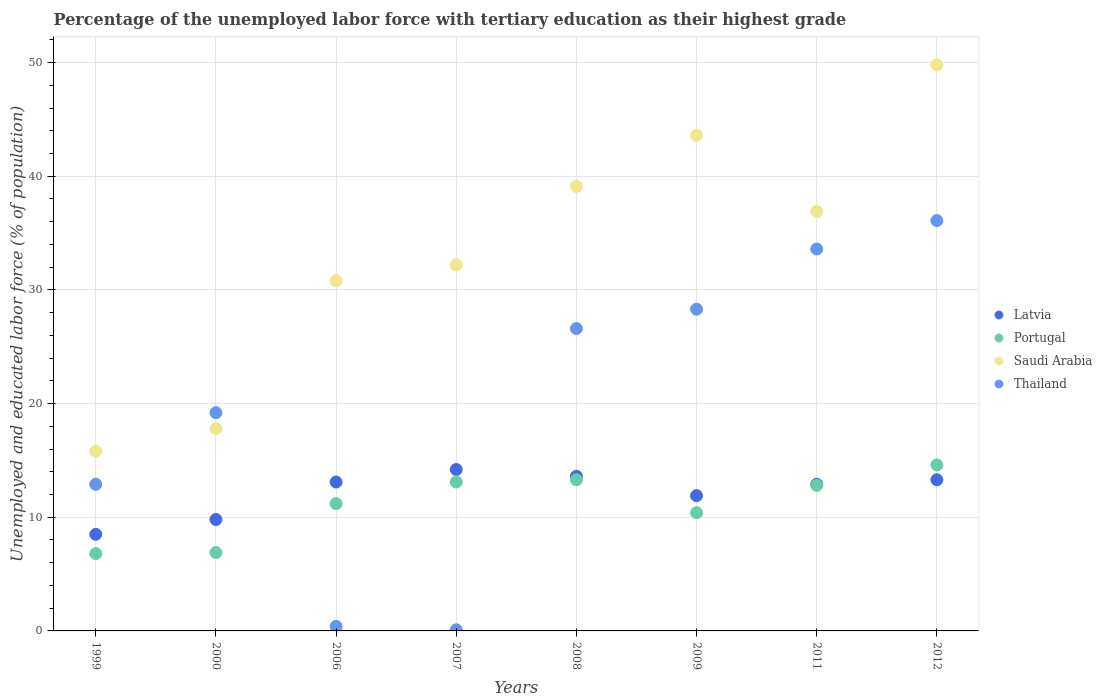How many different coloured dotlines are there?
Offer a very short reply. 4. What is the percentage of the unemployed labor force with tertiary education in Latvia in 1999?
Your response must be concise. 8.5. Across all years, what is the maximum percentage of the unemployed labor force with tertiary education in Thailand?
Ensure brevity in your answer.  36.1. Across all years, what is the minimum percentage of the unemployed labor force with tertiary education in Latvia?
Provide a succinct answer. 8.5. In which year was the percentage of the unemployed labor force with tertiary education in Thailand maximum?
Your response must be concise. 2012. In which year was the percentage of the unemployed labor force with tertiary education in Saudi Arabia minimum?
Your answer should be compact. 1999. What is the total percentage of the unemployed labor force with tertiary education in Portugal in the graph?
Provide a succinct answer. 89.1. What is the difference between the percentage of the unemployed labor force with tertiary education in Latvia in 2006 and that in 2007?
Your answer should be very brief. -1.1. What is the difference between the percentage of the unemployed labor force with tertiary education in Latvia in 2006 and the percentage of the unemployed labor force with tertiary education in Saudi Arabia in 2012?
Your answer should be compact. -36.7. What is the average percentage of the unemployed labor force with tertiary education in Portugal per year?
Your answer should be very brief. 11.14. In the year 2000, what is the difference between the percentage of the unemployed labor force with tertiary education in Saudi Arabia and percentage of the unemployed labor force with tertiary education in Latvia?
Provide a short and direct response. 8. What is the ratio of the percentage of the unemployed labor force with tertiary education in Latvia in 2007 to that in 2009?
Ensure brevity in your answer.  1.19. What is the difference between the highest and the second highest percentage of the unemployed labor force with tertiary education in Saudi Arabia?
Give a very brief answer. 6.2. What is the difference between the highest and the lowest percentage of the unemployed labor force with tertiary education in Thailand?
Make the answer very short. 36. In how many years, is the percentage of the unemployed labor force with tertiary education in Thailand greater than the average percentage of the unemployed labor force with tertiary education in Thailand taken over all years?
Offer a very short reply. 4. Is it the case that in every year, the sum of the percentage of the unemployed labor force with tertiary education in Latvia and percentage of the unemployed labor force with tertiary education in Saudi Arabia  is greater than the percentage of the unemployed labor force with tertiary education in Thailand?
Your answer should be compact. Yes. Does the percentage of the unemployed labor force with tertiary education in Portugal monotonically increase over the years?
Offer a terse response. No. Is the percentage of the unemployed labor force with tertiary education in Thailand strictly greater than the percentage of the unemployed labor force with tertiary education in Latvia over the years?
Your answer should be compact. No. Is the percentage of the unemployed labor force with tertiary education in Latvia strictly less than the percentage of the unemployed labor force with tertiary education in Saudi Arabia over the years?
Provide a short and direct response. Yes. How many dotlines are there?
Offer a terse response. 4. How many years are there in the graph?
Give a very brief answer. 8. Are the values on the major ticks of Y-axis written in scientific E-notation?
Offer a terse response. No. Does the graph contain any zero values?
Keep it short and to the point. No. What is the title of the graph?
Your answer should be very brief. Percentage of the unemployed labor force with tertiary education as their highest grade. Does "Gambia, The" appear as one of the legend labels in the graph?
Provide a short and direct response. No. What is the label or title of the X-axis?
Ensure brevity in your answer.  Years. What is the label or title of the Y-axis?
Your response must be concise. Unemployed and educated labor force (% of population). What is the Unemployed and educated labor force (% of population) in Latvia in 1999?
Keep it short and to the point. 8.5. What is the Unemployed and educated labor force (% of population) in Portugal in 1999?
Offer a terse response. 6.8. What is the Unemployed and educated labor force (% of population) of Saudi Arabia in 1999?
Provide a succinct answer. 15.8. What is the Unemployed and educated labor force (% of population) in Thailand in 1999?
Provide a short and direct response. 12.9. What is the Unemployed and educated labor force (% of population) in Latvia in 2000?
Your answer should be compact. 9.8. What is the Unemployed and educated labor force (% of population) of Portugal in 2000?
Provide a short and direct response. 6.9. What is the Unemployed and educated labor force (% of population) in Saudi Arabia in 2000?
Your answer should be very brief. 17.8. What is the Unemployed and educated labor force (% of population) of Thailand in 2000?
Give a very brief answer. 19.2. What is the Unemployed and educated labor force (% of population) of Latvia in 2006?
Your answer should be very brief. 13.1. What is the Unemployed and educated labor force (% of population) in Portugal in 2006?
Provide a succinct answer. 11.2. What is the Unemployed and educated labor force (% of population) of Saudi Arabia in 2006?
Your response must be concise. 30.8. What is the Unemployed and educated labor force (% of population) in Thailand in 2006?
Provide a short and direct response. 0.4. What is the Unemployed and educated labor force (% of population) of Latvia in 2007?
Keep it short and to the point. 14.2. What is the Unemployed and educated labor force (% of population) of Portugal in 2007?
Your answer should be compact. 13.1. What is the Unemployed and educated labor force (% of population) of Saudi Arabia in 2007?
Ensure brevity in your answer.  32.2. What is the Unemployed and educated labor force (% of population) of Thailand in 2007?
Give a very brief answer. 0.1. What is the Unemployed and educated labor force (% of population) in Latvia in 2008?
Give a very brief answer. 13.6. What is the Unemployed and educated labor force (% of population) of Portugal in 2008?
Ensure brevity in your answer.  13.3. What is the Unemployed and educated labor force (% of population) in Saudi Arabia in 2008?
Your answer should be compact. 39.1. What is the Unemployed and educated labor force (% of population) in Thailand in 2008?
Offer a terse response. 26.6. What is the Unemployed and educated labor force (% of population) in Latvia in 2009?
Keep it short and to the point. 11.9. What is the Unemployed and educated labor force (% of population) of Portugal in 2009?
Make the answer very short. 10.4. What is the Unemployed and educated labor force (% of population) in Saudi Arabia in 2009?
Your response must be concise. 43.6. What is the Unemployed and educated labor force (% of population) of Thailand in 2009?
Provide a short and direct response. 28.3. What is the Unemployed and educated labor force (% of population) of Latvia in 2011?
Ensure brevity in your answer.  12.9. What is the Unemployed and educated labor force (% of population) of Portugal in 2011?
Make the answer very short. 12.8. What is the Unemployed and educated labor force (% of population) of Saudi Arabia in 2011?
Your answer should be compact. 36.9. What is the Unemployed and educated labor force (% of population) in Thailand in 2011?
Make the answer very short. 33.6. What is the Unemployed and educated labor force (% of population) in Latvia in 2012?
Provide a short and direct response. 13.3. What is the Unemployed and educated labor force (% of population) in Portugal in 2012?
Your answer should be compact. 14.6. What is the Unemployed and educated labor force (% of population) of Saudi Arabia in 2012?
Your answer should be compact. 49.8. What is the Unemployed and educated labor force (% of population) of Thailand in 2012?
Ensure brevity in your answer.  36.1. Across all years, what is the maximum Unemployed and educated labor force (% of population) in Latvia?
Keep it short and to the point. 14.2. Across all years, what is the maximum Unemployed and educated labor force (% of population) of Portugal?
Give a very brief answer. 14.6. Across all years, what is the maximum Unemployed and educated labor force (% of population) of Saudi Arabia?
Make the answer very short. 49.8. Across all years, what is the maximum Unemployed and educated labor force (% of population) of Thailand?
Provide a short and direct response. 36.1. Across all years, what is the minimum Unemployed and educated labor force (% of population) of Latvia?
Provide a short and direct response. 8.5. Across all years, what is the minimum Unemployed and educated labor force (% of population) of Portugal?
Offer a terse response. 6.8. Across all years, what is the minimum Unemployed and educated labor force (% of population) of Saudi Arabia?
Provide a short and direct response. 15.8. Across all years, what is the minimum Unemployed and educated labor force (% of population) of Thailand?
Ensure brevity in your answer.  0.1. What is the total Unemployed and educated labor force (% of population) in Latvia in the graph?
Your answer should be very brief. 97.3. What is the total Unemployed and educated labor force (% of population) of Portugal in the graph?
Make the answer very short. 89.1. What is the total Unemployed and educated labor force (% of population) in Saudi Arabia in the graph?
Offer a very short reply. 266. What is the total Unemployed and educated labor force (% of population) in Thailand in the graph?
Keep it short and to the point. 157.2. What is the difference between the Unemployed and educated labor force (% of population) of Latvia in 1999 and that in 2000?
Your response must be concise. -1.3. What is the difference between the Unemployed and educated labor force (% of population) of Portugal in 1999 and that in 2000?
Your response must be concise. -0.1. What is the difference between the Unemployed and educated labor force (% of population) in Saudi Arabia in 1999 and that in 2006?
Provide a succinct answer. -15. What is the difference between the Unemployed and educated labor force (% of population) of Thailand in 1999 and that in 2006?
Ensure brevity in your answer.  12.5. What is the difference between the Unemployed and educated labor force (% of population) in Portugal in 1999 and that in 2007?
Your answer should be compact. -6.3. What is the difference between the Unemployed and educated labor force (% of population) in Saudi Arabia in 1999 and that in 2007?
Make the answer very short. -16.4. What is the difference between the Unemployed and educated labor force (% of population) of Latvia in 1999 and that in 2008?
Offer a terse response. -5.1. What is the difference between the Unemployed and educated labor force (% of population) in Portugal in 1999 and that in 2008?
Offer a very short reply. -6.5. What is the difference between the Unemployed and educated labor force (% of population) in Saudi Arabia in 1999 and that in 2008?
Make the answer very short. -23.3. What is the difference between the Unemployed and educated labor force (% of population) of Thailand in 1999 and that in 2008?
Ensure brevity in your answer.  -13.7. What is the difference between the Unemployed and educated labor force (% of population) of Saudi Arabia in 1999 and that in 2009?
Make the answer very short. -27.8. What is the difference between the Unemployed and educated labor force (% of population) of Thailand in 1999 and that in 2009?
Give a very brief answer. -15.4. What is the difference between the Unemployed and educated labor force (% of population) of Latvia in 1999 and that in 2011?
Offer a terse response. -4.4. What is the difference between the Unemployed and educated labor force (% of population) in Portugal in 1999 and that in 2011?
Offer a very short reply. -6. What is the difference between the Unemployed and educated labor force (% of population) of Saudi Arabia in 1999 and that in 2011?
Offer a very short reply. -21.1. What is the difference between the Unemployed and educated labor force (% of population) of Thailand in 1999 and that in 2011?
Provide a short and direct response. -20.7. What is the difference between the Unemployed and educated labor force (% of population) in Latvia in 1999 and that in 2012?
Provide a short and direct response. -4.8. What is the difference between the Unemployed and educated labor force (% of population) of Portugal in 1999 and that in 2012?
Offer a terse response. -7.8. What is the difference between the Unemployed and educated labor force (% of population) of Saudi Arabia in 1999 and that in 2012?
Your response must be concise. -34. What is the difference between the Unemployed and educated labor force (% of population) of Thailand in 1999 and that in 2012?
Offer a terse response. -23.2. What is the difference between the Unemployed and educated labor force (% of population) of Portugal in 2000 and that in 2006?
Provide a succinct answer. -4.3. What is the difference between the Unemployed and educated labor force (% of population) in Saudi Arabia in 2000 and that in 2006?
Provide a short and direct response. -13. What is the difference between the Unemployed and educated labor force (% of population) in Thailand in 2000 and that in 2006?
Keep it short and to the point. 18.8. What is the difference between the Unemployed and educated labor force (% of population) of Latvia in 2000 and that in 2007?
Make the answer very short. -4.4. What is the difference between the Unemployed and educated labor force (% of population) in Portugal in 2000 and that in 2007?
Make the answer very short. -6.2. What is the difference between the Unemployed and educated labor force (% of population) in Saudi Arabia in 2000 and that in 2007?
Your response must be concise. -14.4. What is the difference between the Unemployed and educated labor force (% of population) in Thailand in 2000 and that in 2007?
Make the answer very short. 19.1. What is the difference between the Unemployed and educated labor force (% of population) of Latvia in 2000 and that in 2008?
Your answer should be very brief. -3.8. What is the difference between the Unemployed and educated labor force (% of population) of Portugal in 2000 and that in 2008?
Your answer should be very brief. -6.4. What is the difference between the Unemployed and educated labor force (% of population) in Saudi Arabia in 2000 and that in 2008?
Provide a succinct answer. -21.3. What is the difference between the Unemployed and educated labor force (% of population) of Saudi Arabia in 2000 and that in 2009?
Ensure brevity in your answer.  -25.8. What is the difference between the Unemployed and educated labor force (% of population) of Thailand in 2000 and that in 2009?
Provide a succinct answer. -9.1. What is the difference between the Unemployed and educated labor force (% of population) in Latvia in 2000 and that in 2011?
Your response must be concise. -3.1. What is the difference between the Unemployed and educated labor force (% of population) in Portugal in 2000 and that in 2011?
Ensure brevity in your answer.  -5.9. What is the difference between the Unemployed and educated labor force (% of population) in Saudi Arabia in 2000 and that in 2011?
Your answer should be very brief. -19.1. What is the difference between the Unemployed and educated labor force (% of population) of Thailand in 2000 and that in 2011?
Keep it short and to the point. -14.4. What is the difference between the Unemployed and educated labor force (% of population) of Saudi Arabia in 2000 and that in 2012?
Your answer should be compact. -32. What is the difference between the Unemployed and educated labor force (% of population) in Thailand in 2000 and that in 2012?
Keep it short and to the point. -16.9. What is the difference between the Unemployed and educated labor force (% of population) of Latvia in 2006 and that in 2007?
Your answer should be compact. -1.1. What is the difference between the Unemployed and educated labor force (% of population) in Portugal in 2006 and that in 2007?
Provide a short and direct response. -1.9. What is the difference between the Unemployed and educated labor force (% of population) of Latvia in 2006 and that in 2008?
Provide a short and direct response. -0.5. What is the difference between the Unemployed and educated labor force (% of population) in Portugal in 2006 and that in 2008?
Your answer should be compact. -2.1. What is the difference between the Unemployed and educated labor force (% of population) of Saudi Arabia in 2006 and that in 2008?
Offer a very short reply. -8.3. What is the difference between the Unemployed and educated labor force (% of population) of Thailand in 2006 and that in 2008?
Your response must be concise. -26.2. What is the difference between the Unemployed and educated labor force (% of population) in Thailand in 2006 and that in 2009?
Your answer should be compact. -27.9. What is the difference between the Unemployed and educated labor force (% of population) of Latvia in 2006 and that in 2011?
Make the answer very short. 0.2. What is the difference between the Unemployed and educated labor force (% of population) of Portugal in 2006 and that in 2011?
Your response must be concise. -1.6. What is the difference between the Unemployed and educated labor force (% of population) of Thailand in 2006 and that in 2011?
Provide a short and direct response. -33.2. What is the difference between the Unemployed and educated labor force (% of population) of Portugal in 2006 and that in 2012?
Keep it short and to the point. -3.4. What is the difference between the Unemployed and educated labor force (% of population) of Saudi Arabia in 2006 and that in 2012?
Your answer should be compact. -19. What is the difference between the Unemployed and educated labor force (% of population) in Thailand in 2006 and that in 2012?
Offer a very short reply. -35.7. What is the difference between the Unemployed and educated labor force (% of population) of Latvia in 2007 and that in 2008?
Your response must be concise. 0.6. What is the difference between the Unemployed and educated labor force (% of population) in Saudi Arabia in 2007 and that in 2008?
Your response must be concise. -6.9. What is the difference between the Unemployed and educated labor force (% of population) in Thailand in 2007 and that in 2008?
Your answer should be compact. -26.5. What is the difference between the Unemployed and educated labor force (% of population) in Thailand in 2007 and that in 2009?
Give a very brief answer. -28.2. What is the difference between the Unemployed and educated labor force (% of population) of Latvia in 2007 and that in 2011?
Make the answer very short. 1.3. What is the difference between the Unemployed and educated labor force (% of population) of Portugal in 2007 and that in 2011?
Provide a short and direct response. 0.3. What is the difference between the Unemployed and educated labor force (% of population) in Saudi Arabia in 2007 and that in 2011?
Your response must be concise. -4.7. What is the difference between the Unemployed and educated labor force (% of population) in Thailand in 2007 and that in 2011?
Keep it short and to the point. -33.5. What is the difference between the Unemployed and educated labor force (% of population) in Latvia in 2007 and that in 2012?
Keep it short and to the point. 0.9. What is the difference between the Unemployed and educated labor force (% of population) of Portugal in 2007 and that in 2012?
Your response must be concise. -1.5. What is the difference between the Unemployed and educated labor force (% of population) in Saudi Arabia in 2007 and that in 2012?
Offer a terse response. -17.6. What is the difference between the Unemployed and educated labor force (% of population) of Thailand in 2007 and that in 2012?
Give a very brief answer. -36. What is the difference between the Unemployed and educated labor force (% of population) in Latvia in 2008 and that in 2009?
Keep it short and to the point. 1.7. What is the difference between the Unemployed and educated labor force (% of population) in Portugal in 2008 and that in 2009?
Keep it short and to the point. 2.9. What is the difference between the Unemployed and educated labor force (% of population) of Thailand in 2008 and that in 2009?
Give a very brief answer. -1.7. What is the difference between the Unemployed and educated labor force (% of population) in Latvia in 2008 and that in 2011?
Make the answer very short. 0.7. What is the difference between the Unemployed and educated labor force (% of population) of Portugal in 2008 and that in 2011?
Make the answer very short. 0.5. What is the difference between the Unemployed and educated labor force (% of population) in Portugal in 2008 and that in 2012?
Make the answer very short. -1.3. What is the difference between the Unemployed and educated labor force (% of population) of Saudi Arabia in 2008 and that in 2012?
Your answer should be compact. -10.7. What is the difference between the Unemployed and educated labor force (% of population) of Thailand in 2008 and that in 2012?
Keep it short and to the point. -9.5. What is the difference between the Unemployed and educated labor force (% of population) of Latvia in 2009 and that in 2012?
Provide a succinct answer. -1.4. What is the difference between the Unemployed and educated labor force (% of population) of Portugal in 2009 and that in 2012?
Your answer should be very brief. -4.2. What is the difference between the Unemployed and educated labor force (% of population) in Latvia in 2011 and that in 2012?
Your answer should be very brief. -0.4. What is the difference between the Unemployed and educated labor force (% of population) of Portugal in 2011 and that in 2012?
Offer a very short reply. -1.8. What is the difference between the Unemployed and educated labor force (% of population) in Latvia in 1999 and the Unemployed and educated labor force (% of population) in Portugal in 2000?
Provide a short and direct response. 1.6. What is the difference between the Unemployed and educated labor force (% of population) of Latvia in 1999 and the Unemployed and educated labor force (% of population) of Saudi Arabia in 2000?
Provide a succinct answer. -9.3. What is the difference between the Unemployed and educated labor force (% of population) of Saudi Arabia in 1999 and the Unemployed and educated labor force (% of population) of Thailand in 2000?
Offer a terse response. -3.4. What is the difference between the Unemployed and educated labor force (% of population) in Latvia in 1999 and the Unemployed and educated labor force (% of population) in Saudi Arabia in 2006?
Provide a short and direct response. -22.3. What is the difference between the Unemployed and educated labor force (% of population) of Latvia in 1999 and the Unemployed and educated labor force (% of population) of Portugal in 2007?
Ensure brevity in your answer.  -4.6. What is the difference between the Unemployed and educated labor force (% of population) of Latvia in 1999 and the Unemployed and educated labor force (% of population) of Saudi Arabia in 2007?
Ensure brevity in your answer.  -23.7. What is the difference between the Unemployed and educated labor force (% of population) in Portugal in 1999 and the Unemployed and educated labor force (% of population) in Saudi Arabia in 2007?
Offer a very short reply. -25.4. What is the difference between the Unemployed and educated labor force (% of population) of Portugal in 1999 and the Unemployed and educated labor force (% of population) of Thailand in 2007?
Make the answer very short. 6.7. What is the difference between the Unemployed and educated labor force (% of population) of Saudi Arabia in 1999 and the Unemployed and educated labor force (% of population) of Thailand in 2007?
Ensure brevity in your answer.  15.7. What is the difference between the Unemployed and educated labor force (% of population) in Latvia in 1999 and the Unemployed and educated labor force (% of population) in Portugal in 2008?
Offer a terse response. -4.8. What is the difference between the Unemployed and educated labor force (% of population) of Latvia in 1999 and the Unemployed and educated labor force (% of population) of Saudi Arabia in 2008?
Give a very brief answer. -30.6. What is the difference between the Unemployed and educated labor force (% of population) of Latvia in 1999 and the Unemployed and educated labor force (% of population) of Thailand in 2008?
Keep it short and to the point. -18.1. What is the difference between the Unemployed and educated labor force (% of population) of Portugal in 1999 and the Unemployed and educated labor force (% of population) of Saudi Arabia in 2008?
Offer a terse response. -32.3. What is the difference between the Unemployed and educated labor force (% of population) in Portugal in 1999 and the Unemployed and educated labor force (% of population) in Thailand in 2008?
Offer a very short reply. -19.8. What is the difference between the Unemployed and educated labor force (% of population) in Saudi Arabia in 1999 and the Unemployed and educated labor force (% of population) in Thailand in 2008?
Provide a succinct answer. -10.8. What is the difference between the Unemployed and educated labor force (% of population) of Latvia in 1999 and the Unemployed and educated labor force (% of population) of Saudi Arabia in 2009?
Keep it short and to the point. -35.1. What is the difference between the Unemployed and educated labor force (% of population) of Latvia in 1999 and the Unemployed and educated labor force (% of population) of Thailand in 2009?
Give a very brief answer. -19.8. What is the difference between the Unemployed and educated labor force (% of population) of Portugal in 1999 and the Unemployed and educated labor force (% of population) of Saudi Arabia in 2009?
Make the answer very short. -36.8. What is the difference between the Unemployed and educated labor force (% of population) in Portugal in 1999 and the Unemployed and educated labor force (% of population) in Thailand in 2009?
Make the answer very short. -21.5. What is the difference between the Unemployed and educated labor force (% of population) of Saudi Arabia in 1999 and the Unemployed and educated labor force (% of population) of Thailand in 2009?
Offer a very short reply. -12.5. What is the difference between the Unemployed and educated labor force (% of population) in Latvia in 1999 and the Unemployed and educated labor force (% of population) in Saudi Arabia in 2011?
Make the answer very short. -28.4. What is the difference between the Unemployed and educated labor force (% of population) of Latvia in 1999 and the Unemployed and educated labor force (% of population) of Thailand in 2011?
Provide a succinct answer. -25.1. What is the difference between the Unemployed and educated labor force (% of population) of Portugal in 1999 and the Unemployed and educated labor force (% of population) of Saudi Arabia in 2011?
Offer a very short reply. -30.1. What is the difference between the Unemployed and educated labor force (% of population) in Portugal in 1999 and the Unemployed and educated labor force (% of population) in Thailand in 2011?
Your answer should be very brief. -26.8. What is the difference between the Unemployed and educated labor force (% of population) of Saudi Arabia in 1999 and the Unemployed and educated labor force (% of population) of Thailand in 2011?
Ensure brevity in your answer.  -17.8. What is the difference between the Unemployed and educated labor force (% of population) in Latvia in 1999 and the Unemployed and educated labor force (% of population) in Saudi Arabia in 2012?
Your answer should be compact. -41.3. What is the difference between the Unemployed and educated labor force (% of population) of Latvia in 1999 and the Unemployed and educated labor force (% of population) of Thailand in 2012?
Keep it short and to the point. -27.6. What is the difference between the Unemployed and educated labor force (% of population) in Portugal in 1999 and the Unemployed and educated labor force (% of population) in Saudi Arabia in 2012?
Keep it short and to the point. -43. What is the difference between the Unemployed and educated labor force (% of population) in Portugal in 1999 and the Unemployed and educated labor force (% of population) in Thailand in 2012?
Ensure brevity in your answer.  -29.3. What is the difference between the Unemployed and educated labor force (% of population) in Saudi Arabia in 1999 and the Unemployed and educated labor force (% of population) in Thailand in 2012?
Ensure brevity in your answer.  -20.3. What is the difference between the Unemployed and educated labor force (% of population) of Latvia in 2000 and the Unemployed and educated labor force (% of population) of Portugal in 2006?
Provide a succinct answer. -1.4. What is the difference between the Unemployed and educated labor force (% of population) in Latvia in 2000 and the Unemployed and educated labor force (% of population) in Saudi Arabia in 2006?
Provide a short and direct response. -21. What is the difference between the Unemployed and educated labor force (% of population) of Latvia in 2000 and the Unemployed and educated labor force (% of population) of Thailand in 2006?
Keep it short and to the point. 9.4. What is the difference between the Unemployed and educated labor force (% of population) of Portugal in 2000 and the Unemployed and educated labor force (% of population) of Saudi Arabia in 2006?
Your response must be concise. -23.9. What is the difference between the Unemployed and educated labor force (% of population) in Saudi Arabia in 2000 and the Unemployed and educated labor force (% of population) in Thailand in 2006?
Ensure brevity in your answer.  17.4. What is the difference between the Unemployed and educated labor force (% of population) in Latvia in 2000 and the Unemployed and educated labor force (% of population) in Saudi Arabia in 2007?
Provide a short and direct response. -22.4. What is the difference between the Unemployed and educated labor force (% of population) of Latvia in 2000 and the Unemployed and educated labor force (% of population) of Thailand in 2007?
Make the answer very short. 9.7. What is the difference between the Unemployed and educated labor force (% of population) in Portugal in 2000 and the Unemployed and educated labor force (% of population) in Saudi Arabia in 2007?
Offer a very short reply. -25.3. What is the difference between the Unemployed and educated labor force (% of population) in Portugal in 2000 and the Unemployed and educated labor force (% of population) in Thailand in 2007?
Offer a very short reply. 6.8. What is the difference between the Unemployed and educated labor force (% of population) of Saudi Arabia in 2000 and the Unemployed and educated labor force (% of population) of Thailand in 2007?
Ensure brevity in your answer.  17.7. What is the difference between the Unemployed and educated labor force (% of population) of Latvia in 2000 and the Unemployed and educated labor force (% of population) of Portugal in 2008?
Make the answer very short. -3.5. What is the difference between the Unemployed and educated labor force (% of population) in Latvia in 2000 and the Unemployed and educated labor force (% of population) in Saudi Arabia in 2008?
Provide a short and direct response. -29.3. What is the difference between the Unemployed and educated labor force (% of population) in Latvia in 2000 and the Unemployed and educated labor force (% of population) in Thailand in 2008?
Offer a very short reply. -16.8. What is the difference between the Unemployed and educated labor force (% of population) in Portugal in 2000 and the Unemployed and educated labor force (% of population) in Saudi Arabia in 2008?
Offer a very short reply. -32.2. What is the difference between the Unemployed and educated labor force (% of population) of Portugal in 2000 and the Unemployed and educated labor force (% of population) of Thailand in 2008?
Keep it short and to the point. -19.7. What is the difference between the Unemployed and educated labor force (% of population) of Saudi Arabia in 2000 and the Unemployed and educated labor force (% of population) of Thailand in 2008?
Make the answer very short. -8.8. What is the difference between the Unemployed and educated labor force (% of population) of Latvia in 2000 and the Unemployed and educated labor force (% of population) of Saudi Arabia in 2009?
Keep it short and to the point. -33.8. What is the difference between the Unemployed and educated labor force (% of population) in Latvia in 2000 and the Unemployed and educated labor force (% of population) in Thailand in 2009?
Your response must be concise. -18.5. What is the difference between the Unemployed and educated labor force (% of population) in Portugal in 2000 and the Unemployed and educated labor force (% of population) in Saudi Arabia in 2009?
Provide a succinct answer. -36.7. What is the difference between the Unemployed and educated labor force (% of population) of Portugal in 2000 and the Unemployed and educated labor force (% of population) of Thailand in 2009?
Your answer should be very brief. -21.4. What is the difference between the Unemployed and educated labor force (% of population) of Latvia in 2000 and the Unemployed and educated labor force (% of population) of Saudi Arabia in 2011?
Provide a succinct answer. -27.1. What is the difference between the Unemployed and educated labor force (% of population) of Latvia in 2000 and the Unemployed and educated labor force (% of population) of Thailand in 2011?
Keep it short and to the point. -23.8. What is the difference between the Unemployed and educated labor force (% of population) in Portugal in 2000 and the Unemployed and educated labor force (% of population) in Saudi Arabia in 2011?
Give a very brief answer. -30. What is the difference between the Unemployed and educated labor force (% of population) of Portugal in 2000 and the Unemployed and educated labor force (% of population) of Thailand in 2011?
Give a very brief answer. -26.7. What is the difference between the Unemployed and educated labor force (% of population) in Saudi Arabia in 2000 and the Unemployed and educated labor force (% of population) in Thailand in 2011?
Provide a succinct answer. -15.8. What is the difference between the Unemployed and educated labor force (% of population) in Latvia in 2000 and the Unemployed and educated labor force (% of population) in Portugal in 2012?
Keep it short and to the point. -4.8. What is the difference between the Unemployed and educated labor force (% of population) in Latvia in 2000 and the Unemployed and educated labor force (% of population) in Thailand in 2012?
Give a very brief answer. -26.3. What is the difference between the Unemployed and educated labor force (% of population) of Portugal in 2000 and the Unemployed and educated labor force (% of population) of Saudi Arabia in 2012?
Your answer should be compact. -42.9. What is the difference between the Unemployed and educated labor force (% of population) in Portugal in 2000 and the Unemployed and educated labor force (% of population) in Thailand in 2012?
Keep it short and to the point. -29.2. What is the difference between the Unemployed and educated labor force (% of population) of Saudi Arabia in 2000 and the Unemployed and educated labor force (% of population) of Thailand in 2012?
Offer a very short reply. -18.3. What is the difference between the Unemployed and educated labor force (% of population) of Latvia in 2006 and the Unemployed and educated labor force (% of population) of Portugal in 2007?
Your response must be concise. 0. What is the difference between the Unemployed and educated labor force (% of population) of Latvia in 2006 and the Unemployed and educated labor force (% of population) of Saudi Arabia in 2007?
Your answer should be very brief. -19.1. What is the difference between the Unemployed and educated labor force (% of population) of Portugal in 2006 and the Unemployed and educated labor force (% of population) of Thailand in 2007?
Make the answer very short. 11.1. What is the difference between the Unemployed and educated labor force (% of population) in Saudi Arabia in 2006 and the Unemployed and educated labor force (% of population) in Thailand in 2007?
Provide a succinct answer. 30.7. What is the difference between the Unemployed and educated labor force (% of population) of Latvia in 2006 and the Unemployed and educated labor force (% of population) of Saudi Arabia in 2008?
Give a very brief answer. -26. What is the difference between the Unemployed and educated labor force (% of population) in Latvia in 2006 and the Unemployed and educated labor force (% of population) in Thailand in 2008?
Keep it short and to the point. -13.5. What is the difference between the Unemployed and educated labor force (% of population) of Portugal in 2006 and the Unemployed and educated labor force (% of population) of Saudi Arabia in 2008?
Your answer should be compact. -27.9. What is the difference between the Unemployed and educated labor force (% of population) of Portugal in 2006 and the Unemployed and educated labor force (% of population) of Thailand in 2008?
Give a very brief answer. -15.4. What is the difference between the Unemployed and educated labor force (% of population) of Latvia in 2006 and the Unemployed and educated labor force (% of population) of Saudi Arabia in 2009?
Provide a short and direct response. -30.5. What is the difference between the Unemployed and educated labor force (% of population) in Latvia in 2006 and the Unemployed and educated labor force (% of population) in Thailand in 2009?
Ensure brevity in your answer.  -15.2. What is the difference between the Unemployed and educated labor force (% of population) of Portugal in 2006 and the Unemployed and educated labor force (% of population) of Saudi Arabia in 2009?
Your response must be concise. -32.4. What is the difference between the Unemployed and educated labor force (% of population) of Portugal in 2006 and the Unemployed and educated labor force (% of population) of Thailand in 2009?
Your answer should be very brief. -17.1. What is the difference between the Unemployed and educated labor force (% of population) in Latvia in 2006 and the Unemployed and educated labor force (% of population) in Saudi Arabia in 2011?
Provide a short and direct response. -23.8. What is the difference between the Unemployed and educated labor force (% of population) of Latvia in 2006 and the Unemployed and educated labor force (% of population) of Thailand in 2011?
Your response must be concise. -20.5. What is the difference between the Unemployed and educated labor force (% of population) of Portugal in 2006 and the Unemployed and educated labor force (% of population) of Saudi Arabia in 2011?
Offer a terse response. -25.7. What is the difference between the Unemployed and educated labor force (% of population) of Portugal in 2006 and the Unemployed and educated labor force (% of population) of Thailand in 2011?
Your answer should be very brief. -22.4. What is the difference between the Unemployed and educated labor force (% of population) of Saudi Arabia in 2006 and the Unemployed and educated labor force (% of population) of Thailand in 2011?
Your answer should be compact. -2.8. What is the difference between the Unemployed and educated labor force (% of population) of Latvia in 2006 and the Unemployed and educated labor force (% of population) of Saudi Arabia in 2012?
Give a very brief answer. -36.7. What is the difference between the Unemployed and educated labor force (% of population) of Latvia in 2006 and the Unemployed and educated labor force (% of population) of Thailand in 2012?
Keep it short and to the point. -23. What is the difference between the Unemployed and educated labor force (% of population) of Portugal in 2006 and the Unemployed and educated labor force (% of population) of Saudi Arabia in 2012?
Give a very brief answer. -38.6. What is the difference between the Unemployed and educated labor force (% of population) in Portugal in 2006 and the Unemployed and educated labor force (% of population) in Thailand in 2012?
Keep it short and to the point. -24.9. What is the difference between the Unemployed and educated labor force (% of population) in Saudi Arabia in 2006 and the Unemployed and educated labor force (% of population) in Thailand in 2012?
Offer a terse response. -5.3. What is the difference between the Unemployed and educated labor force (% of population) of Latvia in 2007 and the Unemployed and educated labor force (% of population) of Saudi Arabia in 2008?
Make the answer very short. -24.9. What is the difference between the Unemployed and educated labor force (% of population) in Portugal in 2007 and the Unemployed and educated labor force (% of population) in Saudi Arabia in 2008?
Provide a short and direct response. -26. What is the difference between the Unemployed and educated labor force (% of population) of Portugal in 2007 and the Unemployed and educated labor force (% of population) of Thailand in 2008?
Your answer should be very brief. -13.5. What is the difference between the Unemployed and educated labor force (% of population) of Latvia in 2007 and the Unemployed and educated labor force (% of population) of Portugal in 2009?
Your answer should be compact. 3.8. What is the difference between the Unemployed and educated labor force (% of population) of Latvia in 2007 and the Unemployed and educated labor force (% of population) of Saudi Arabia in 2009?
Your response must be concise. -29.4. What is the difference between the Unemployed and educated labor force (% of population) of Latvia in 2007 and the Unemployed and educated labor force (% of population) of Thailand in 2009?
Make the answer very short. -14.1. What is the difference between the Unemployed and educated labor force (% of population) in Portugal in 2007 and the Unemployed and educated labor force (% of population) in Saudi Arabia in 2009?
Offer a terse response. -30.5. What is the difference between the Unemployed and educated labor force (% of population) of Portugal in 2007 and the Unemployed and educated labor force (% of population) of Thailand in 2009?
Give a very brief answer. -15.2. What is the difference between the Unemployed and educated labor force (% of population) in Saudi Arabia in 2007 and the Unemployed and educated labor force (% of population) in Thailand in 2009?
Your answer should be compact. 3.9. What is the difference between the Unemployed and educated labor force (% of population) of Latvia in 2007 and the Unemployed and educated labor force (% of population) of Portugal in 2011?
Ensure brevity in your answer.  1.4. What is the difference between the Unemployed and educated labor force (% of population) of Latvia in 2007 and the Unemployed and educated labor force (% of population) of Saudi Arabia in 2011?
Make the answer very short. -22.7. What is the difference between the Unemployed and educated labor force (% of population) in Latvia in 2007 and the Unemployed and educated labor force (% of population) in Thailand in 2011?
Offer a terse response. -19.4. What is the difference between the Unemployed and educated labor force (% of population) of Portugal in 2007 and the Unemployed and educated labor force (% of population) of Saudi Arabia in 2011?
Give a very brief answer. -23.8. What is the difference between the Unemployed and educated labor force (% of population) in Portugal in 2007 and the Unemployed and educated labor force (% of population) in Thailand in 2011?
Your answer should be compact. -20.5. What is the difference between the Unemployed and educated labor force (% of population) in Latvia in 2007 and the Unemployed and educated labor force (% of population) in Portugal in 2012?
Your answer should be very brief. -0.4. What is the difference between the Unemployed and educated labor force (% of population) in Latvia in 2007 and the Unemployed and educated labor force (% of population) in Saudi Arabia in 2012?
Your response must be concise. -35.6. What is the difference between the Unemployed and educated labor force (% of population) of Latvia in 2007 and the Unemployed and educated labor force (% of population) of Thailand in 2012?
Ensure brevity in your answer.  -21.9. What is the difference between the Unemployed and educated labor force (% of population) in Portugal in 2007 and the Unemployed and educated labor force (% of population) in Saudi Arabia in 2012?
Your answer should be very brief. -36.7. What is the difference between the Unemployed and educated labor force (% of population) in Latvia in 2008 and the Unemployed and educated labor force (% of population) in Saudi Arabia in 2009?
Your response must be concise. -30. What is the difference between the Unemployed and educated labor force (% of population) of Latvia in 2008 and the Unemployed and educated labor force (% of population) of Thailand in 2009?
Keep it short and to the point. -14.7. What is the difference between the Unemployed and educated labor force (% of population) in Portugal in 2008 and the Unemployed and educated labor force (% of population) in Saudi Arabia in 2009?
Provide a succinct answer. -30.3. What is the difference between the Unemployed and educated labor force (% of population) of Latvia in 2008 and the Unemployed and educated labor force (% of population) of Saudi Arabia in 2011?
Make the answer very short. -23.3. What is the difference between the Unemployed and educated labor force (% of population) in Latvia in 2008 and the Unemployed and educated labor force (% of population) in Thailand in 2011?
Your answer should be compact. -20. What is the difference between the Unemployed and educated labor force (% of population) of Portugal in 2008 and the Unemployed and educated labor force (% of population) of Saudi Arabia in 2011?
Keep it short and to the point. -23.6. What is the difference between the Unemployed and educated labor force (% of population) of Portugal in 2008 and the Unemployed and educated labor force (% of population) of Thailand in 2011?
Ensure brevity in your answer.  -20.3. What is the difference between the Unemployed and educated labor force (% of population) in Latvia in 2008 and the Unemployed and educated labor force (% of population) in Saudi Arabia in 2012?
Give a very brief answer. -36.2. What is the difference between the Unemployed and educated labor force (% of population) in Latvia in 2008 and the Unemployed and educated labor force (% of population) in Thailand in 2012?
Your answer should be compact. -22.5. What is the difference between the Unemployed and educated labor force (% of population) of Portugal in 2008 and the Unemployed and educated labor force (% of population) of Saudi Arabia in 2012?
Offer a very short reply. -36.5. What is the difference between the Unemployed and educated labor force (% of population) in Portugal in 2008 and the Unemployed and educated labor force (% of population) in Thailand in 2012?
Provide a short and direct response. -22.8. What is the difference between the Unemployed and educated labor force (% of population) of Saudi Arabia in 2008 and the Unemployed and educated labor force (% of population) of Thailand in 2012?
Your answer should be very brief. 3. What is the difference between the Unemployed and educated labor force (% of population) in Latvia in 2009 and the Unemployed and educated labor force (% of population) in Thailand in 2011?
Provide a succinct answer. -21.7. What is the difference between the Unemployed and educated labor force (% of population) of Portugal in 2009 and the Unemployed and educated labor force (% of population) of Saudi Arabia in 2011?
Ensure brevity in your answer.  -26.5. What is the difference between the Unemployed and educated labor force (% of population) in Portugal in 2009 and the Unemployed and educated labor force (% of population) in Thailand in 2011?
Your response must be concise. -23.2. What is the difference between the Unemployed and educated labor force (% of population) in Latvia in 2009 and the Unemployed and educated labor force (% of population) in Portugal in 2012?
Offer a very short reply. -2.7. What is the difference between the Unemployed and educated labor force (% of population) of Latvia in 2009 and the Unemployed and educated labor force (% of population) of Saudi Arabia in 2012?
Your response must be concise. -37.9. What is the difference between the Unemployed and educated labor force (% of population) in Latvia in 2009 and the Unemployed and educated labor force (% of population) in Thailand in 2012?
Give a very brief answer. -24.2. What is the difference between the Unemployed and educated labor force (% of population) of Portugal in 2009 and the Unemployed and educated labor force (% of population) of Saudi Arabia in 2012?
Your answer should be compact. -39.4. What is the difference between the Unemployed and educated labor force (% of population) in Portugal in 2009 and the Unemployed and educated labor force (% of population) in Thailand in 2012?
Your answer should be compact. -25.7. What is the difference between the Unemployed and educated labor force (% of population) of Saudi Arabia in 2009 and the Unemployed and educated labor force (% of population) of Thailand in 2012?
Make the answer very short. 7.5. What is the difference between the Unemployed and educated labor force (% of population) in Latvia in 2011 and the Unemployed and educated labor force (% of population) in Portugal in 2012?
Make the answer very short. -1.7. What is the difference between the Unemployed and educated labor force (% of population) of Latvia in 2011 and the Unemployed and educated labor force (% of population) of Saudi Arabia in 2012?
Your response must be concise. -36.9. What is the difference between the Unemployed and educated labor force (% of population) in Latvia in 2011 and the Unemployed and educated labor force (% of population) in Thailand in 2012?
Your answer should be compact. -23.2. What is the difference between the Unemployed and educated labor force (% of population) in Portugal in 2011 and the Unemployed and educated labor force (% of population) in Saudi Arabia in 2012?
Provide a short and direct response. -37. What is the difference between the Unemployed and educated labor force (% of population) of Portugal in 2011 and the Unemployed and educated labor force (% of population) of Thailand in 2012?
Keep it short and to the point. -23.3. What is the difference between the Unemployed and educated labor force (% of population) in Saudi Arabia in 2011 and the Unemployed and educated labor force (% of population) in Thailand in 2012?
Your answer should be compact. 0.8. What is the average Unemployed and educated labor force (% of population) in Latvia per year?
Keep it short and to the point. 12.16. What is the average Unemployed and educated labor force (% of population) in Portugal per year?
Make the answer very short. 11.14. What is the average Unemployed and educated labor force (% of population) of Saudi Arabia per year?
Your response must be concise. 33.25. What is the average Unemployed and educated labor force (% of population) of Thailand per year?
Offer a very short reply. 19.65. In the year 1999, what is the difference between the Unemployed and educated labor force (% of population) in Latvia and Unemployed and educated labor force (% of population) in Thailand?
Provide a short and direct response. -4.4. In the year 1999, what is the difference between the Unemployed and educated labor force (% of population) in Portugal and Unemployed and educated labor force (% of population) in Thailand?
Ensure brevity in your answer.  -6.1. In the year 1999, what is the difference between the Unemployed and educated labor force (% of population) of Saudi Arabia and Unemployed and educated labor force (% of population) of Thailand?
Make the answer very short. 2.9. In the year 2000, what is the difference between the Unemployed and educated labor force (% of population) of Latvia and Unemployed and educated labor force (% of population) of Thailand?
Keep it short and to the point. -9.4. In the year 2000, what is the difference between the Unemployed and educated labor force (% of population) of Saudi Arabia and Unemployed and educated labor force (% of population) of Thailand?
Keep it short and to the point. -1.4. In the year 2006, what is the difference between the Unemployed and educated labor force (% of population) of Latvia and Unemployed and educated labor force (% of population) of Portugal?
Your answer should be very brief. 1.9. In the year 2006, what is the difference between the Unemployed and educated labor force (% of population) of Latvia and Unemployed and educated labor force (% of population) of Saudi Arabia?
Give a very brief answer. -17.7. In the year 2006, what is the difference between the Unemployed and educated labor force (% of population) in Latvia and Unemployed and educated labor force (% of population) in Thailand?
Provide a succinct answer. 12.7. In the year 2006, what is the difference between the Unemployed and educated labor force (% of population) in Portugal and Unemployed and educated labor force (% of population) in Saudi Arabia?
Give a very brief answer. -19.6. In the year 2006, what is the difference between the Unemployed and educated labor force (% of population) in Portugal and Unemployed and educated labor force (% of population) in Thailand?
Offer a terse response. 10.8. In the year 2006, what is the difference between the Unemployed and educated labor force (% of population) of Saudi Arabia and Unemployed and educated labor force (% of population) of Thailand?
Ensure brevity in your answer.  30.4. In the year 2007, what is the difference between the Unemployed and educated labor force (% of population) in Latvia and Unemployed and educated labor force (% of population) in Saudi Arabia?
Your answer should be very brief. -18. In the year 2007, what is the difference between the Unemployed and educated labor force (% of population) of Latvia and Unemployed and educated labor force (% of population) of Thailand?
Keep it short and to the point. 14.1. In the year 2007, what is the difference between the Unemployed and educated labor force (% of population) in Portugal and Unemployed and educated labor force (% of population) in Saudi Arabia?
Offer a terse response. -19.1. In the year 2007, what is the difference between the Unemployed and educated labor force (% of population) in Saudi Arabia and Unemployed and educated labor force (% of population) in Thailand?
Your response must be concise. 32.1. In the year 2008, what is the difference between the Unemployed and educated labor force (% of population) in Latvia and Unemployed and educated labor force (% of population) in Saudi Arabia?
Your answer should be very brief. -25.5. In the year 2008, what is the difference between the Unemployed and educated labor force (% of population) of Portugal and Unemployed and educated labor force (% of population) of Saudi Arabia?
Provide a short and direct response. -25.8. In the year 2008, what is the difference between the Unemployed and educated labor force (% of population) in Portugal and Unemployed and educated labor force (% of population) in Thailand?
Provide a succinct answer. -13.3. In the year 2009, what is the difference between the Unemployed and educated labor force (% of population) of Latvia and Unemployed and educated labor force (% of population) of Saudi Arabia?
Your answer should be very brief. -31.7. In the year 2009, what is the difference between the Unemployed and educated labor force (% of population) in Latvia and Unemployed and educated labor force (% of population) in Thailand?
Your answer should be very brief. -16.4. In the year 2009, what is the difference between the Unemployed and educated labor force (% of population) in Portugal and Unemployed and educated labor force (% of population) in Saudi Arabia?
Your response must be concise. -33.2. In the year 2009, what is the difference between the Unemployed and educated labor force (% of population) of Portugal and Unemployed and educated labor force (% of population) of Thailand?
Keep it short and to the point. -17.9. In the year 2011, what is the difference between the Unemployed and educated labor force (% of population) of Latvia and Unemployed and educated labor force (% of population) of Portugal?
Provide a succinct answer. 0.1. In the year 2011, what is the difference between the Unemployed and educated labor force (% of population) in Latvia and Unemployed and educated labor force (% of population) in Saudi Arabia?
Make the answer very short. -24. In the year 2011, what is the difference between the Unemployed and educated labor force (% of population) of Latvia and Unemployed and educated labor force (% of population) of Thailand?
Offer a very short reply. -20.7. In the year 2011, what is the difference between the Unemployed and educated labor force (% of population) in Portugal and Unemployed and educated labor force (% of population) in Saudi Arabia?
Your answer should be very brief. -24.1. In the year 2011, what is the difference between the Unemployed and educated labor force (% of population) in Portugal and Unemployed and educated labor force (% of population) in Thailand?
Give a very brief answer. -20.8. In the year 2011, what is the difference between the Unemployed and educated labor force (% of population) in Saudi Arabia and Unemployed and educated labor force (% of population) in Thailand?
Ensure brevity in your answer.  3.3. In the year 2012, what is the difference between the Unemployed and educated labor force (% of population) of Latvia and Unemployed and educated labor force (% of population) of Portugal?
Offer a terse response. -1.3. In the year 2012, what is the difference between the Unemployed and educated labor force (% of population) in Latvia and Unemployed and educated labor force (% of population) in Saudi Arabia?
Provide a short and direct response. -36.5. In the year 2012, what is the difference between the Unemployed and educated labor force (% of population) in Latvia and Unemployed and educated labor force (% of population) in Thailand?
Offer a terse response. -22.8. In the year 2012, what is the difference between the Unemployed and educated labor force (% of population) in Portugal and Unemployed and educated labor force (% of population) in Saudi Arabia?
Ensure brevity in your answer.  -35.2. In the year 2012, what is the difference between the Unemployed and educated labor force (% of population) in Portugal and Unemployed and educated labor force (% of population) in Thailand?
Make the answer very short. -21.5. What is the ratio of the Unemployed and educated labor force (% of population) of Latvia in 1999 to that in 2000?
Provide a succinct answer. 0.87. What is the ratio of the Unemployed and educated labor force (% of population) of Portugal in 1999 to that in 2000?
Ensure brevity in your answer.  0.99. What is the ratio of the Unemployed and educated labor force (% of population) of Saudi Arabia in 1999 to that in 2000?
Offer a very short reply. 0.89. What is the ratio of the Unemployed and educated labor force (% of population) of Thailand in 1999 to that in 2000?
Your response must be concise. 0.67. What is the ratio of the Unemployed and educated labor force (% of population) of Latvia in 1999 to that in 2006?
Your answer should be compact. 0.65. What is the ratio of the Unemployed and educated labor force (% of population) of Portugal in 1999 to that in 2006?
Ensure brevity in your answer.  0.61. What is the ratio of the Unemployed and educated labor force (% of population) in Saudi Arabia in 1999 to that in 2006?
Ensure brevity in your answer.  0.51. What is the ratio of the Unemployed and educated labor force (% of population) of Thailand in 1999 to that in 2006?
Provide a succinct answer. 32.25. What is the ratio of the Unemployed and educated labor force (% of population) in Latvia in 1999 to that in 2007?
Your answer should be very brief. 0.6. What is the ratio of the Unemployed and educated labor force (% of population) of Portugal in 1999 to that in 2007?
Make the answer very short. 0.52. What is the ratio of the Unemployed and educated labor force (% of population) in Saudi Arabia in 1999 to that in 2007?
Your answer should be very brief. 0.49. What is the ratio of the Unemployed and educated labor force (% of population) in Thailand in 1999 to that in 2007?
Your answer should be very brief. 129. What is the ratio of the Unemployed and educated labor force (% of population) of Latvia in 1999 to that in 2008?
Give a very brief answer. 0.62. What is the ratio of the Unemployed and educated labor force (% of population) in Portugal in 1999 to that in 2008?
Give a very brief answer. 0.51. What is the ratio of the Unemployed and educated labor force (% of population) in Saudi Arabia in 1999 to that in 2008?
Offer a very short reply. 0.4. What is the ratio of the Unemployed and educated labor force (% of population) of Thailand in 1999 to that in 2008?
Ensure brevity in your answer.  0.48. What is the ratio of the Unemployed and educated labor force (% of population) in Latvia in 1999 to that in 2009?
Offer a very short reply. 0.71. What is the ratio of the Unemployed and educated labor force (% of population) of Portugal in 1999 to that in 2009?
Provide a succinct answer. 0.65. What is the ratio of the Unemployed and educated labor force (% of population) of Saudi Arabia in 1999 to that in 2009?
Offer a terse response. 0.36. What is the ratio of the Unemployed and educated labor force (% of population) in Thailand in 1999 to that in 2009?
Keep it short and to the point. 0.46. What is the ratio of the Unemployed and educated labor force (% of population) in Latvia in 1999 to that in 2011?
Provide a succinct answer. 0.66. What is the ratio of the Unemployed and educated labor force (% of population) of Portugal in 1999 to that in 2011?
Give a very brief answer. 0.53. What is the ratio of the Unemployed and educated labor force (% of population) of Saudi Arabia in 1999 to that in 2011?
Offer a very short reply. 0.43. What is the ratio of the Unemployed and educated labor force (% of population) in Thailand in 1999 to that in 2011?
Make the answer very short. 0.38. What is the ratio of the Unemployed and educated labor force (% of population) in Latvia in 1999 to that in 2012?
Your answer should be compact. 0.64. What is the ratio of the Unemployed and educated labor force (% of population) in Portugal in 1999 to that in 2012?
Offer a very short reply. 0.47. What is the ratio of the Unemployed and educated labor force (% of population) in Saudi Arabia in 1999 to that in 2012?
Offer a very short reply. 0.32. What is the ratio of the Unemployed and educated labor force (% of population) of Thailand in 1999 to that in 2012?
Ensure brevity in your answer.  0.36. What is the ratio of the Unemployed and educated labor force (% of population) of Latvia in 2000 to that in 2006?
Give a very brief answer. 0.75. What is the ratio of the Unemployed and educated labor force (% of population) in Portugal in 2000 to that in 2006?
Give a very brief answer. 0.62. What is the ratio of the Unemployed and educated labor force (% of population) of Saudi Arabia in 2000 to that in 2006?
Offer a very short reply. 0.58. What is the ratio of the Unemployed and educated labor force (% of population) in Thailand in 2000 to that in 2006?
Ensure brevity in your answer.  48. What is the ratio of the Unemployed and educated labor force (% of population) in Latvia in 2000 to that in 2007?
Your answer should be compact. 0.69. What is the ratio of the Unemployed and educated labor force (% of population) in Portugal in 2000 to that in 2007?
Give a very brief answer. 0.53. What is the ratio of the Unemployed and educated labor force (% of population) of Saudi Arabia in 2000 to that in 2007?
Offer a terse response. 0.55. What is the ratio of the Unemployed and educated labor force (% of population) in Thailand in 2000 to that in 2007?
Offer a very short reply. 192. What is the ratio of the Unemployed and educated labor force (% of population) of Latvia in 2000 to that in 2008?
Keep it short and to the point. 0.72. What is the ratio of the Unemployed and educated labor force (% of population) in Portugal in 2000 to that in 2008?
Keep it short and to the point. 0.52. What is the ratio of the Unemployed and educated labor force (% of population) of Saudi Arabia in 2000 to that in 2008?
Keep it short and to the point. 0.46. What is the ratio of the Unemployed and educated labor force (% of population) of Thailand in 2000 to that in 2008?
Provide a short and direct response. 0.72. What is the ratio of the Unemployed and educated labor force (% of population) in Latvia in 2000 to that in 2009?
Give a very brief answer. 0.82. What is the ratio of the Unemployed and educated labor force (% of population) of Portugal in 2000 to that in 2009?
Make the answer very short. 0.66. What is the ratio of the Unemployed and educated labor force (% of population) of Saudi Arabia in 2000 to that in 2009?
Offer a very short reply. 0.41. What is the ratio of the Unemployed and educated labor force (% of population) of Thailand in 2000 to that in 2009?
Your answer should be compact. 0.68. What is the ratio of the Unemployed and educated labor force (% of population) of Latvia in 2000 to that in 2011?
Keep it short and to the point. 0.76. What is the ratio of the Unemployed and educated labor force (% of population) of Portugal in 2000 to that in 2011?
Keep it short and to the point. 0.54. What is the ratio of the Unemployed and educated labor force (% of population) in Saudi Arabia in 2000 to that in 2011?
Your response must be concise. 0.48. What is the ratio of the Unemployed and educated labor force (% of population) of Latvia in 2000 to that in 2012?
Offer a very short reply. 0.74. What is the ratio of the Unemployed and educated labor force (% of population) in Portugal in 2000 to that in 2012?
Your response must be concise. 0.47. What is the ratio of the Unemployed and educated labor force (% of population) of Saudi Arabia in 2000 to that in 2012?
Ensure brevity in your answer.  0.36. What is the ratio of the Unemployed and educated labor force (% of population) in Thailand in 2000 to that in 2012?
Provide a short and direct response. 0.53. What is the ratio of the Unemployed and educated labor force (% of population) in Latvia in 2006 to that in 2007?
Make the answer very short. 0.92. What is the ratio of the Unemployed and educated labor force (% of population) in Portugal in 2006 to that in 2007?
Give a very brief answer. 0.85. What is the ratio of the Unemployed and educated labor force (% of population) of Saudi Arabia in 2006 to that in 2007?
Ensure brevity in your answer.  0.96. What is the ratio of the Unemployed and educated labor force (% of population) in Thailand in 2006 to that in 2007?
Offer a very short reply. 4. What is the ratio of the Unemployed and educated labor force (% of population) of Latvia in 2006 to that in 2008?
Your response must be concise. 0.96. What is the ratio of the Unemployed and educated labor force (% of population) in Portugal in 2006 to that in 2008?
Your answer should be very brief. 0.84. What is the ratio of the Unemployed and educated labor force (% of population) in Saudi Arabia in 2006 to that in 2008?
Make the answer very short. 0.79. What is the ratio of the Unemployed and educated labor force (% of population) of Thailand in 2006 to that in 2008?
Your response must be concise. 0.01. What is the ratio of the Unemployed and educated labor force (% of population) of Latvia in 2006 to that in 2009?
Offer a terse response. 1.1. What is the ratio of the Unemployed and educated labor force (% of population) of Saudi Arabia in 2006 to that in 2009?
Offer a terse response. 0.71. What is the ratio of the Unemployed and educated labor force (% of population) of Thailand in 2006 to that in 2009?
Your answer should be very brief. 0.01. What is the ratio of the Unemployed and educated labor force (% of population) in Latvia in 2006 to that in 2011?
Your answer should be compact. 1.02. What is the ratio of the Unemployed and educated labor force (% of population) in Portugal in 2006 to that in 2011?
Keep it short and to the point. 0.88. What is the ratio of the Unemployed and educated labor force (% of population) in Saudi Arabia in 2006 to that in 2011?
Offer a terse response. 0.83. What is the ratio of the Unemployed and educated labor force (% of population) of Thailand in 2006 to that in 2011?
Give a very brief answer. 0.01. What is the ratio of the Unemployed and educated labor force (% of population) of Latvia in 2006 to that in 2012?
Give a very brief answer. 0.98. What is the ratio of the Unemployed and educated labor force (% of population) of Portugal in 2006 to that in 2012?
Provide a short and direct response. 0.77. What is the ratio of the Unemployed and educated labor force (% of population) in Saudi Arabia in 2006 to that in 2012?
Provide a short and direct response. 0.62. What is the ratio of the Unemployed and educated labor force (% of population) in Thailand in 2006 to that in 2012?
Offer a terse response. 0.01. What is the ratio of the Unemployed and educated labor force (% of population) of Latvia in 2007 to that in 2008?
Provide a short and direct response. 1.04. What is the ratio of the Unemployed and educated labor force (% of population) in Saudi Arabia in 2007 to that in 2008?
Give a very brief answer. 0.82. What is the ratio of the Unemployed and educated labor force (% of population) of Thailand in 2007 to that in 2008?
Make the answer very short. 0. What is the ratio of the Unemployed and educated labor force (% of population) in Latvia in 2007 to that in 2009?
Your response must be concise. 1.19. What is the ratio of the Unemployed and educated labor force (% of population) of Portugal in 2007 to that in 2009?
Ensure brevity in your answer.  1.26. What is the ratio of the Unemployed and educated labor force (% of population) in Saudi Arabia in 2007 to that in 2009?
Offer a terse response. 0.74. What is the ratio of the Unemployed and educated labor force (% of population) in Thailand in 2007 to that in 2009?
Your answer should be compact. 0. What is the ratio of the Unemployed and educated labor force (% of population) in Latvia in 2007 to that in 2011?
Ensure brevity in your answer.  1.1. What is the ratio of the Unemployed and educated labor force (% of population) of Portugal in 2007 to that in 2011?
Keep it short and to the point. 1.02. What is the ratio of the Unemployed and educated labor force (% of population) in Saudi Arabia in 2007 to that in 2011?
Provide a succinct answer. 0.87. What is the ratio of the Unemployed and educated labor force (% of population) in Thailand in 2007 to that in 2011?
Keep it short and to the point. 0. What is the ratio of the Unemployed and educated labor force (% of population) of Latvia in 2007 to that in 2012?
Your answer should be compact. 1.07. What is the ratio of the Unemployed and educated labor force (% of population) of Portugal in 2007 to that in 2012?
Offer a very short reply. 0.9. What is the ratio of the Unemployed and educated labor force (% of population) of Saudi Arabia in 2007 to that in 2012?
Offer a terse response. 0.65. What is the ratio of the Unemployed and educated labor force (% of population) in Thailand in 2007 to that in 2012?
Offer a very short reply. 0. What is the ratio of the Unemployed and educated labor force (% of population) in Portugal in 2008 to that in 2009?
Make the answer very short. 1.28. What is the ratio of the Unemployed and educated labor force (% of population) of Saudi Arabia in 2008 to that in 2009?
Provide a short and direct response. 0.9. What is the ratio of the Unemployed and educated labor force (% of population) in Thailand in 2008 to that in 2009?
Your answer should be compact. 0.94. What is the ratio of the Unemployed and educated labor force (% of population) in Latvia in 2008 to that in 2011?
Provide a succinct answer. 1.05. What is the ratio of the Unemployed and educated labor force (% of population) of Portugal in 2008 to that in 2011?
Your answer should be very brief. 1.04. What is the ratio of the Unemployed and educated labor force (% of population) of Saudi Arabia in 2008 to that in 2011?
Your answer should be very brief. 1.06. What is the ratio of the Unemployed and educated labor force (% of population) of Thailand in 2008 to that in 2011?
Your response must be concise. 0.79. What is the ratio of the Unemployed and educated labor force (% of population) of Latvia in 2008 to that in 2012?
Provide a succinct answer. 1.02. What is the ratio of the Unemployed and educated labor force (% of population) in Portugal in 2008 to that in 2012?
Give a very brief answer. 0.91. What is the ratio of the Unemployed and educated labor force (% of population) of Saudi Arabia in 2008 to that in 2012?
Your answer should be very brief. 0.79. What is the ratio of the Unemployed and educated labor force (% of population) of Thailand in 2008 to that in 2012?
Keep it short and to the point. 0.74. What is the ratio of the Unemployed and educated labor force (% of population) of Latvia in 2009 to that in 2011?
Your answer should be very brief. 0.92. What is the ratio of the Unemployed and educated labor force (% of population) of Portugal in 2009 to that in 2011?
Keep it short and to the point. 0.81. What is the ratio of the Unemployed and educated labor force (% of population) in Saudi Arabia in 2009 to that in 2011?
Ensure brevity in your answer.  1.18. What is the ratio of the Unemployed and educated labor force (% of population) of Thailand in 2009 to that in 2011?
Ensure brevity in your answer.  0.84. What is the ratio of the Unemployed and educated labor force (% of population) in Latvia in 2009 to that in 2012?
Make the answer very short. 0.89. What is the ratio of the Unemployed and educated labor force (% of population) of Portugal in 2009 to that in 2012?
Provide a succinct answer. 0.71. What is the ratio of the Unemployed and educated labor force (% of population) in Saudi Arabia in 2009 to that in 2012?
Offer a very short reply. 0.88. What is the ratio of the Unemployed and educated labor force (% of population) of Thailand in 2009 to that in 2012?
Your response must be concise. 0.78. What is the ratio of the Unemployed and educated labor force (% of population) of Latvia in 2011 to that in 2012?
Give a very brief answer. 0.97. What is the ratio of the Unemployed and educated labor force (% of population) in Portugal in 2011 to that in 2012?
Offer a very short reply. 0.88. What is the ratio of the Unemployed and educated labor force (% of population) of Saudi Arabia in 2011 to that in 2012?
Offer a very short reply. 0.74. What is the ratio of the Unemployed and educated labor force (% of population) of Thailand in 2011 to that in 2012?
Provide a short and direct response. 0.93. What is the difference between the highest and the second highest Unemployed and educated labor force (% of population) in Latvia?
Make the answer very short. 0.6. What is the difference between the highest and the second highest Unemployed and educated labor force (% of population) of Thailand?
Offer a very short reply. 2.5. What is the difference between the highest and the lowest Unemployed and educated labor force (% of population) of Latvia?
Provide a short and direct response. 5.7. What is the difference between the highest and the lowest Unemployed and educated labor force (% of population) in Portugal?
Provide a succinct answer. 7.8. What is the difference between the highest and the lowest Unemployed and educated labor force (% of population) in Thailand?
Your answer should be compact. 36. 